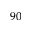<formula> <loc_0><loc_0><loc_500><loc_500>^ { 9 0 }</formula> 